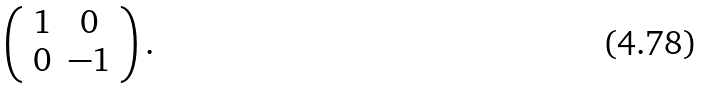Convert formula to latex. <formula><loc_0><loc_0><loc_500><loc_500>\left ( \begin{array} { r c } 1 & 0 \\ 0 & - 1 \end{array} \right ) .</formula> 